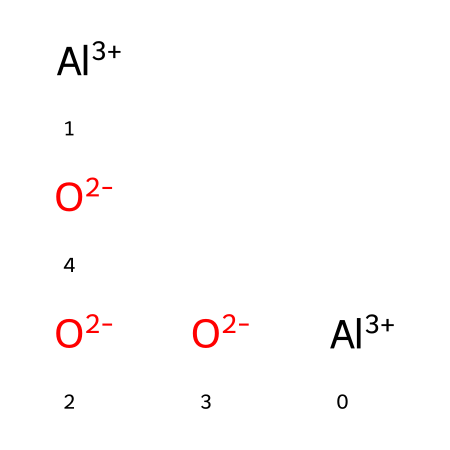What is the total number of aluminum atoms in this structure? There are two aluminum ions (Al+3) present in the SMILES representation, indicated by the two occurrences of "Al+3".
Answer: two How many oxygen atoms are present in the aluminum oxide structure? The SMILES representation contains three occurrences of "O-2", indicating there are three oxygen ions present.
Answer: three What is the charge of an aluminum ion in this compound? Each aluminum ion is shown as "Al+3", which means it has a charge of +3.
Answer: +3 What type of bonding is likely present in aluminum oxide? The presence of both positively charged aluminum ions and negatively charged oxygen ions suggests ionic bonding between these ions.
Answer: ionic Why is aluminum oxide commonly used in smartphone screens? Aluminum oxide has high hardness and durability, making it resistant to scratches and impacts, which are critical properties for materials used in screens.
Answer: durability What is the ratio of aluminum atoms to oxygen atoms in aluminum oxide? The structure contains 2 aluminum atoms and 3 oxygen atoms, leading to a ratio expressed as 2:3.
Answer: 2:3 